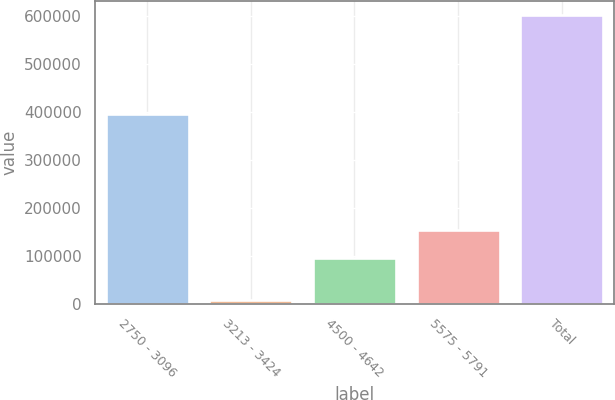Convert chart to OTSL. <chart><loc_0><loc_0><loc_500><loc_500><bar_chart><fcel>2750 - 3096<fcel>3213 - 3424<fcel>4500 - 4642<fcel>5575 - 5791<fcel>Total<nl><fcel>395784<fcel>8834<fcel>95964<fcel>155268<fcel>601870<nl></chart> 